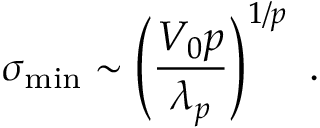Convert formula to latex. <formula><loc_0><loc_0><loc_500><loc_500>\sigma _ { \min } \sim \left ( \frac { V _ { 0 } p } { \lambda _ { p } } \right ) ^ { 1 / p } \ .</formula> 